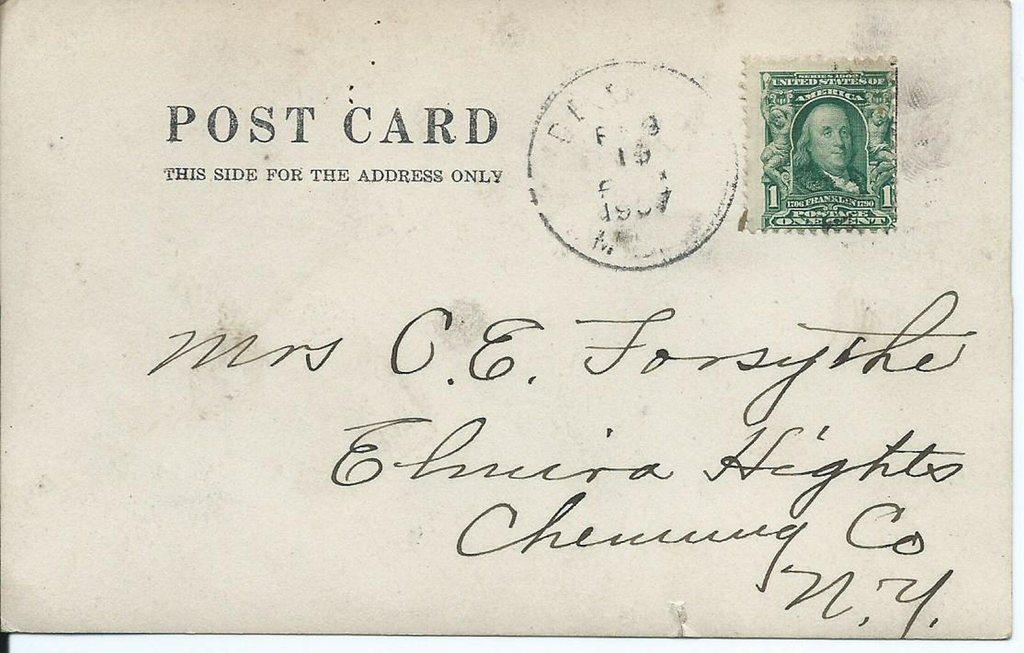<image>
Describe the image concisely. A post card with a dollar sign stamp has writing in cursive on it. 